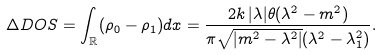Convert formula to latex. <formula><loc_0><loc_0><loc_500><loc_500>\Delta D O S = \int _ { \mathbb { R } } ( \rho _ { 0 } - \rho _ { 1 } ) d x = \frac { 2 k \, | \lambda | \theta ( \lambda ^ { 2 } - m ^ { 2 } ) } { \pi \sqrt { | m ^ { 2 } - \lambda ^ { 2 } | } ( \lambda ^ { 2 } - \lambda _ { 1 } ^ { 2 } ) } .</formula> 